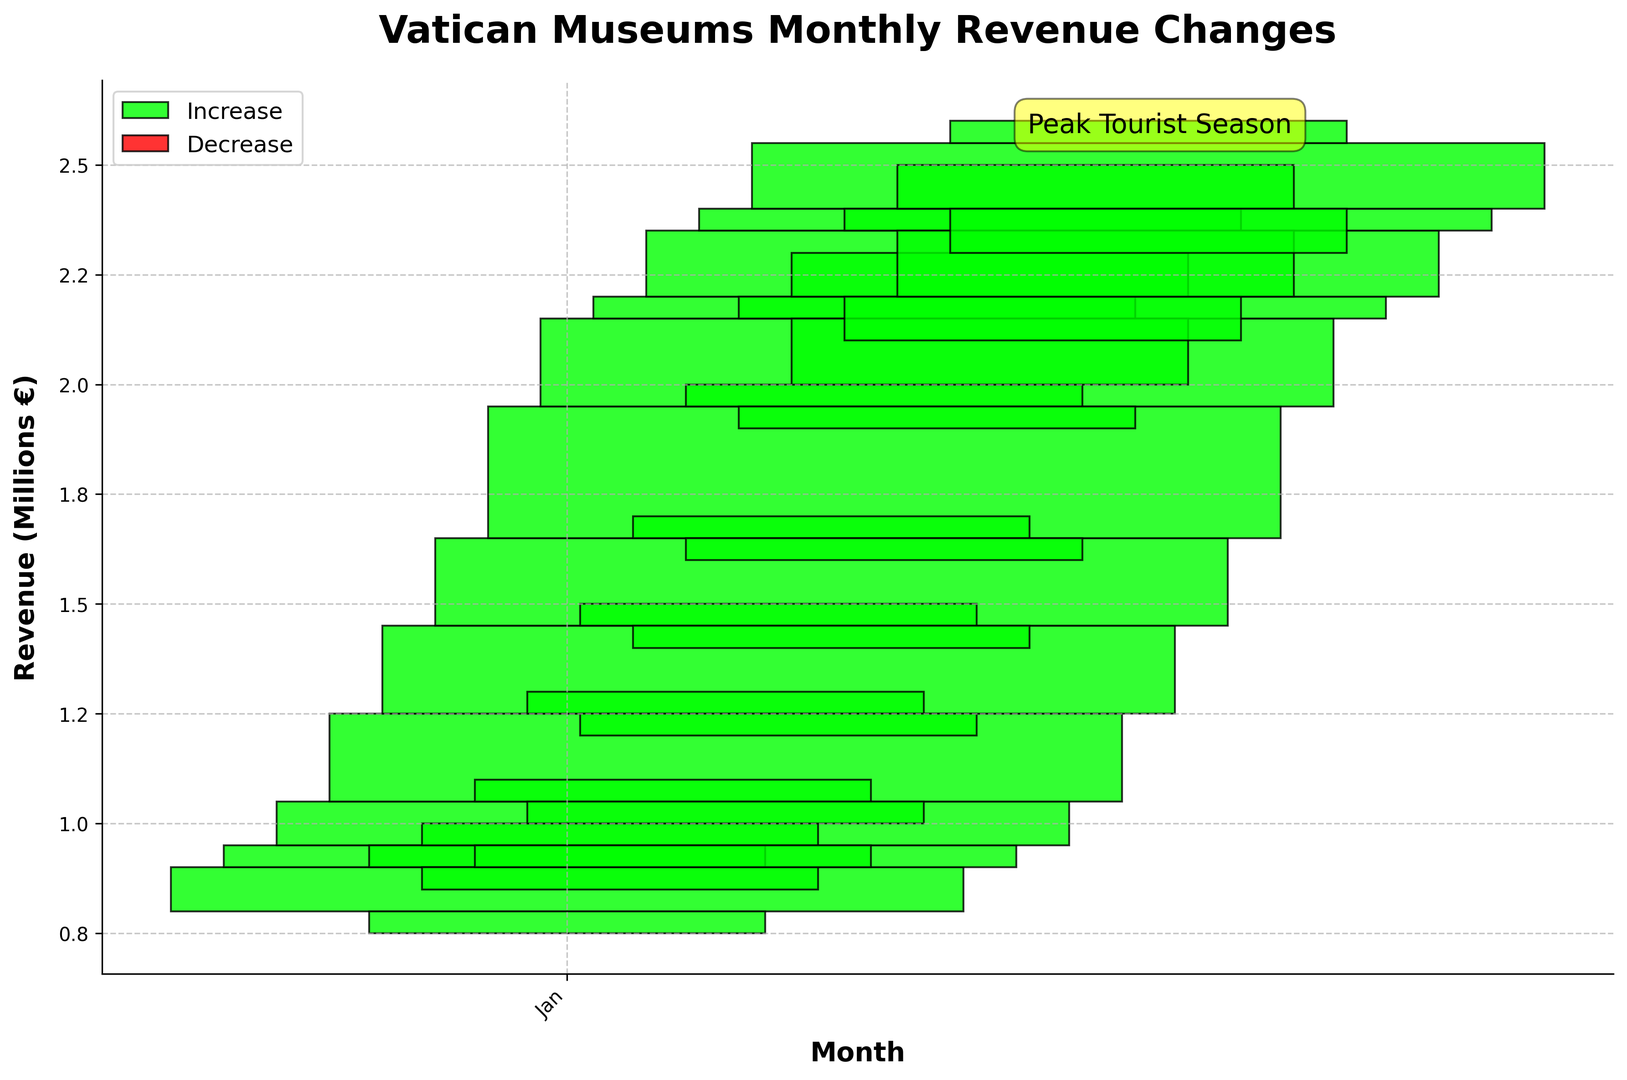Which month experienced the highest revenue increase? The green bars represent months with increased revenue compared to their opening values. The tallest green bar is located in December, indicating the highest increase in revenue.
Answer: December Which month saw the least change in revenue? To determine the month with the least change, we compare the lengths of the smallest bars, both green and red. January shows a relatively small bar, indicating minimal revenue change.
Answer: January How does the revenue in April compare to July? Revenue increased in both months, but the heights of the green bars indicate that the revenue increase is higher in July compared to April. By visualizing, July's bar is much taller than April's.
Answer: July's increase is higher What is the general trend in revenue from January to December? From January to December, the height of the bars consistently increases, indicating a general upward trend in revenue over the months.
Answer: Upward trend Which months are part of the peak tourist season? Peak tourist season is annotated in the upper right with an arrow pointing to July, indicating that the peak tourist season includes July and subsequent months as they have higher revenue.
Answer: July onwards Is there any month where the revenue decreased compared to the opening value? Red bars represent the months where revenue decreased. In this chart, there are no red bars, indicating no months with a decrease in revenue.
Answer: None How much, approximately, did the revenue increase in August? The green bar in August shows an increase, so we subtract the opening value (1,950,000) from the closing value (2,150,000). This results in an increase of approximately 200,000 euros.
Answer: 200,000 euros Which month had the highest closing revenue, and what was it? The closing revenue is represented by the topmost point of the bars. December’s bar reaches the highest point. The closing revenue in December was 2,550,000 euros.
Answer: December, 2,550,000 euros When did the Vatican Museums' revenue reach 2 million euros for the first time? The chart shows green bars reaching the 2 million euros mark for the first time in July. July is the first month when the revenue crosses this threshold.
Answer: July 